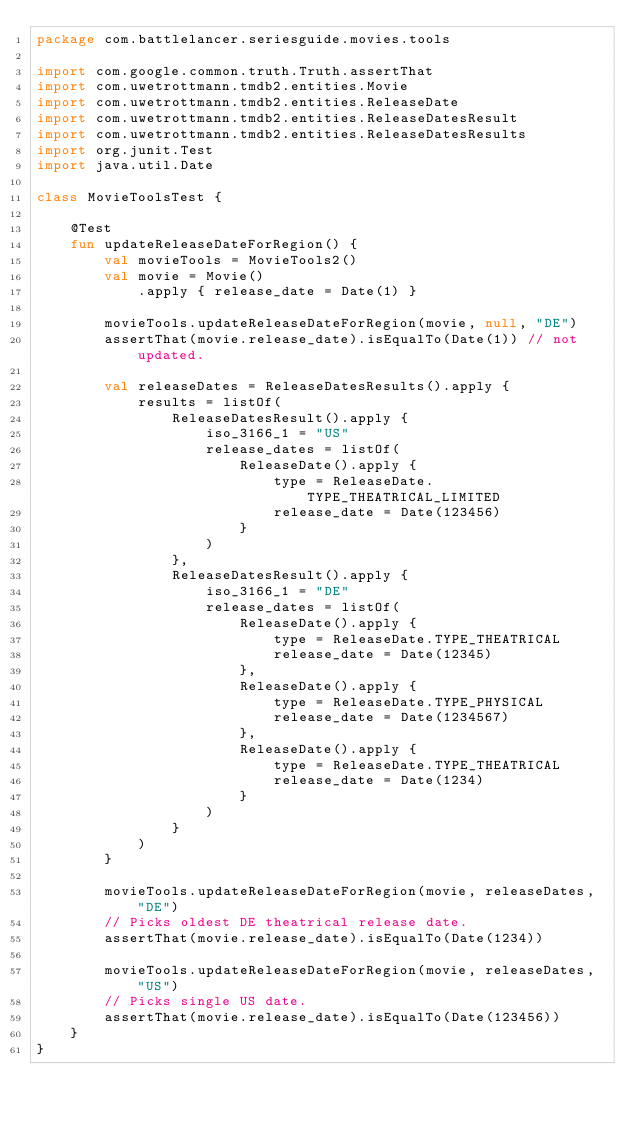<code> <loc_0><loc_0><loc_500><loc_500><_Kotlin_>package com.battlelancer.seriesguide.movies.tools

import com.google.common.truth.Truth.assertThat
import com.uwetrottmann.tmdb2.entities.Movie
import com.uwetrottmann.tmdb2.entities.ReleaseDate
import com.uwetrottmann.tmdb2.entities.ReleaseDatesResult
import com.uwetrottmann.tmdb2.entities.ReleaseDatesResults
import org.junit.Test
import java.util.Date

class MovieToolsTest {

    @Test
    fun updateReleaseDateForRegion() {
        val movieTools = MovieTools2()
        val movie = Movie()
            .apply { release_date = Date(1) }

        movieTools.updateReleaseDateForRegion(movie, null, "DE")
        assertThat(movie.release_date).isEqualTo(Date(1)) // not updated.

        val releaseDates = ReleaseDatesResults().apply {
            results = listOf(
                ReleaseDatesResult().apply {
                    iso_3166_1 = "US"
                    release_dates = listOf(
                        ReleaseDate().apply {
                            type = ReleaseDate.TYPE_THEATRICAL_LIMITED
                            release_date = Date(123456)
                        }
                    )
                },
                ReleaseDatesResult().apply {
                    iso_3166_1 = "DE"
                    release_dates = listOf(
                        ReleaseDate().apply {
                            type = ReleaseDate.TYPE_THEATRICAL
                            release_date = Date(12345)
                        },
                        ReleaseDate().apply {
                            type = ReleaseDate.TYPE_PHYSICAL
                            release_date = Date(1234567)
                        },
                        ReleaseDate().apply {
                            type = ReleaseDate.TYPE_THEATRICAL
                            release_date = Date(1234)
                        }
                    )
                }
            )
        }

        movieTools.updateReleaseDateForRegion(movie, releaseDates, "DE")
        // Picks oldest DE theatrical release date.
        assertThat(movie.release_date).isEqualTo(Date(1234))

        movieTools.updateReleaseDateForRegion(movie, releaseDates, "US")
        // Picks single US date.
        assertThat(movie.release_date).isEqualTo(Date(123456))
    }
}</code> 